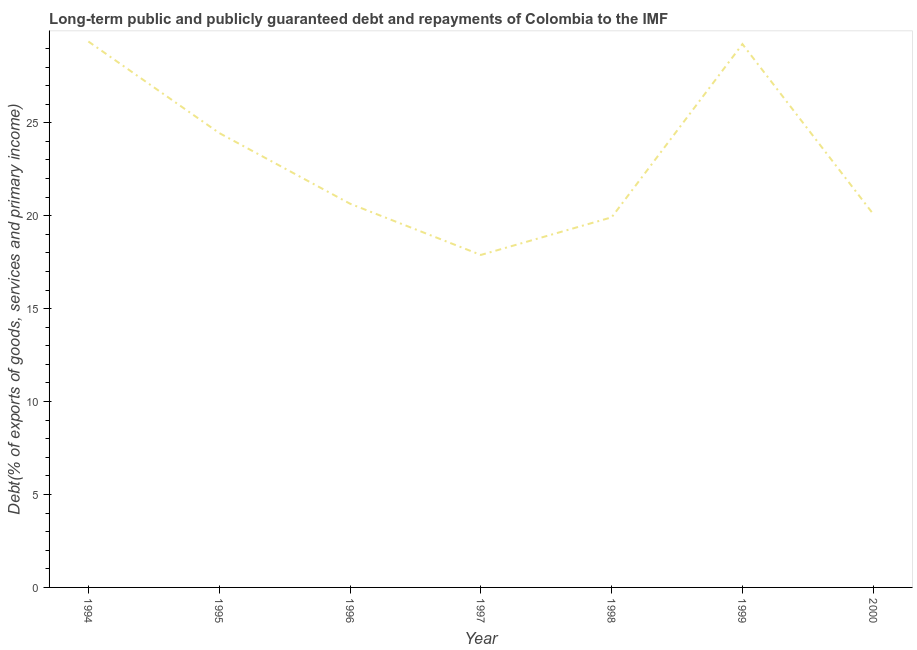What is the debt service in 1995?
Give a very brief answer. 24.45. Across all years, what is the maximum debt service?
Provide a succinct answer. 29.38. Across all years, what is the minimum debt service?
Offer a very short reply. 17.89. What is the sum of the debt service?
Offer a very short reply. 161.6. What is the difference between the debt service in 1996 and 2000?
Ensure brevity in your answer.  0.56. What is the average debt service per year?
Provide a short and direct response. 23.09. What is the median debt service?
Keep it short and to the point. 20.65. Do a majority of the years between 1997 and 2000 (inclusive) have debt service greater than 17 %?
Give a very brief answer. Yes. What is the ratio of the debt service in 1995 to that in 1999?
Offer a very short reply. 0.84. Is the difference between the debt service in 1994 and 2000 greater than the difference between any two years?
Your response must be concise. No. What is the difference between the highest and the second highest debt service?
Offer a terse response. 0.14. What is the difference between the highest and the lowest debt service?
Your answer should be very brief. 11.49. In how many years, is the debt service greater than the average debt service taken over all years?
Keep it short and to the point. 3. How many lines are there?
Ensure brevity in your answer.  1. How many years are there in the graph?
Your answer should be compact. 7. What is the difference between two consecutive major ticks on the Y-axis?
Provide a succinct answer. 5. Are the values on the major ticks of Y-axis written in scientific E-notation?
Make the answer very short. No. Does the graph contain grids?
Ensure brevity in your answer.  No. What is the title of the graph?
Offer a terse response. Long-term public and publicly guaranteed debt and repayments of Colombia to the IMF. What is the label or title of the X-axis?
Your answer should be compact. Year. What is the label or title of the Y-axis?
Provide a succinct answer. Debt(% of exports of goods, services and primary income). What is the Debt(% of exports of goods, services and primary income) of 1994?
Make the answer very short. 29.38. What is the Debt(% of exports of goods, services and primary income) of 1995?
Ensure brevity in your answer.  24.45. What is the Debt(% of exports of goods, services and primary income) in 1996?
Ensure brevity in your answer.  20.65. What is the Debt(% of exports of goods, services and primary income) in 1997?
Ensure brevity in your answer.  17.89. What is the Debt(% of exports of goods, services and primary income) of 1998?
Your response must be concise. 19.91. What is the Debt(% of exports of goods, services and primary income) in 1999?
Provide a short and direct response. 29.23. What is the Debt(% of exports of goods, services and primary income) of 2000?
Your answer should be compact. 20.09. What is the difference between the Debt(% of exports of goods, services and primary income) in 1994 and 1995?
Give a very brief answer. 4.92. What is the difference between the Debt(% of exports of goods, services and primary income) in 1994 and 1996?
Offer a very short reply. 8.73. What is the difference between the Debt(% of exports of goods, services and primary income) in 1994 and 1997?
Ensure brevity in your answer.  11.49. What is the difference between the Debt(% of exports of goods, services and primary income) in 1994 and 1998?
Give a very brief answer. 9.46. What is the difference between the Debt(% of exports of goods, services and primary income) in 1994 and 1999?
Provide a short and direct response. 0.14. What is the difference between the Debt(% of exports of goods, services and primary income) in 1994 and 2000?
Provide a succinct answer. 9.28. What is the difference between the Debt(% of exports of goods, services and primary income) in 1995 and 1996?
Your answer should be compact. 3.8. What is the difference between the Debt(% of exports of goods, services and primary income) in 1995 and 1997?
Make the answer very short. 6.56. What is the difference between the Debt(% of exports of goods, services and primary income) in 1995 and 1998?
Provide a short and direct response. 4.54. What is the difference between the Debt(% of exports of goods, services and primary income) in 1995 and 1999?
Make the answer very short. -4.78. What is the difference between the Debt(% of exports of goods, services and primary income) in 1995 and 2000?
Your answer should be compact. 4.36. What is the difference between the Debt(% of exports of goods, services and primary income) in 1996 and 1997?
Your response must be concise. 2.76. What is the difference between the Debt(% of exports of goods, services and primary income) in 1996 and 1998?
Your response must be concise. 0.73. What is the difference between the Debt(% of exports of goods, services and primary income) in 1996 and 1999?
Your response must be concise. -8.59. What is the difference between the Debt(% of exports of goods, services and primary income) in 1996 and 2000?
Keep it short and to the point. 0.56. What is the difference between the Debt(% of exports of goods, services and primary income) in 1997 and 1998?
Make the answer very short. -2.02. What is the difference between the Debt(% of exports of goods, services and primary income) in 1997 and 1999?
Make the answer very short. -11.34. What is the difference between the Debt(% of exports of goods, services and primary income) in 1997 and 2000?
Your answer should be compact. -2.2. What is the difference between the Debt(% of exports of goods, services and primary income) in 1998 and 1999?
Your answer should be compact. -9.32. What is the difference between the Debt(% of exports of goods, services and primary income) in 1998 and 2000?
Ensure brevity in your answer.  -0.18. What is the difference between the Debt(% of exports of goods, services and primary income) in 1999 and 2000?
Provide a succinct answer. 9.14. What is the ratio of the Debt(% of exports of goods, services and primary income) in 1994 to that in 1995?
Offer a terse response. 1.2. What is the ratio of the Debt(% of exports of goods, services and primary income) in 1994 to that in 1996?
Give a very brief answer. 1.42. What is the ratio of the Debt(% of exports of goods, services and primary income) in 1994 to that in 1997?
Keep it short and to the point. 1.64. What is the ratio of the Debt(% of exports of goods, services and primary income) in 1994 to that in 1998?
Ensure brevity in your answer.  1.48. What is the ratio of the Debt(% of exports of goods, services and primary income) in 1994 to that in 1999?
Provide a succinct answer. 1. What is the ratio of the Debt(% of exports of goods, services and primary income) in 1994 to that in 2000?
Offer a very short reply. 1.46. What is the ratio of the Debt(% of exports of goods, services and primary income) in 1995 to that in 1996?
Give a very brief answer. 1.18. What is the ratio of the Debt(% of exports of goods, services and primary income) in 1995 to that in 1997?
Provide a short and direct response. 1.37. What is the ratio of the Debt(% of exports of goods, services and primary income) in 1995 to that in 1998?
Your response must be concise. 1.23. What is the ratio of the Debt(% of exports of goods, services and primary income) in 1995 to that in 1999?
Offer a terse response. 0.84. What is the ratio of the Debt(% of exports of goods, services and primary income) in 1995 to that in 2000?
Give a very brief answer. 1.22. What is the ratio of the Debt(% of exports of goods, services and primary income) in 1996 to that in 1997?
Ensure brevity in your answer.  1.15. What is the ratio of the Debt(% of exports of goods, services and primary income) in 1996 to that in 1999?
Keep it short and to the point. 0.71. What is the ratio of the Debt(% of exports of goods, services and primary income) in 1996 to that in 2000?
Keep it short and to the point. 1.03. What is the ratio of the Debt(% of exports of goods, services and primary income) in 1997 to that in 1998?
Offer a very short reply. 0.9. What is the ratio of the Debt(% of exports of goods, services and primary income) in 1997 to that in 1999?
Keep it short and to the point. 0.61. What is the ratio of the Debt(% of exports of goods, services and primary income) in 1997 to that in 2000?
Provide a short and direct response. 0.89. What is the ratio of the Debt(% of exports of goods, services and primary income) in 1998 to that in 1999?
Keep it short and to the point. 0.68. What is the ratio of the Debt(% of exports of goods, services and primary income) in 1998 to that in 2000?
Offer a very short reply. 0.99. What is the ratio of the Debt(% of exports of goods, services and primary income) in 1999 to that in 2000?
Provide a succinct answer. 1.46. 